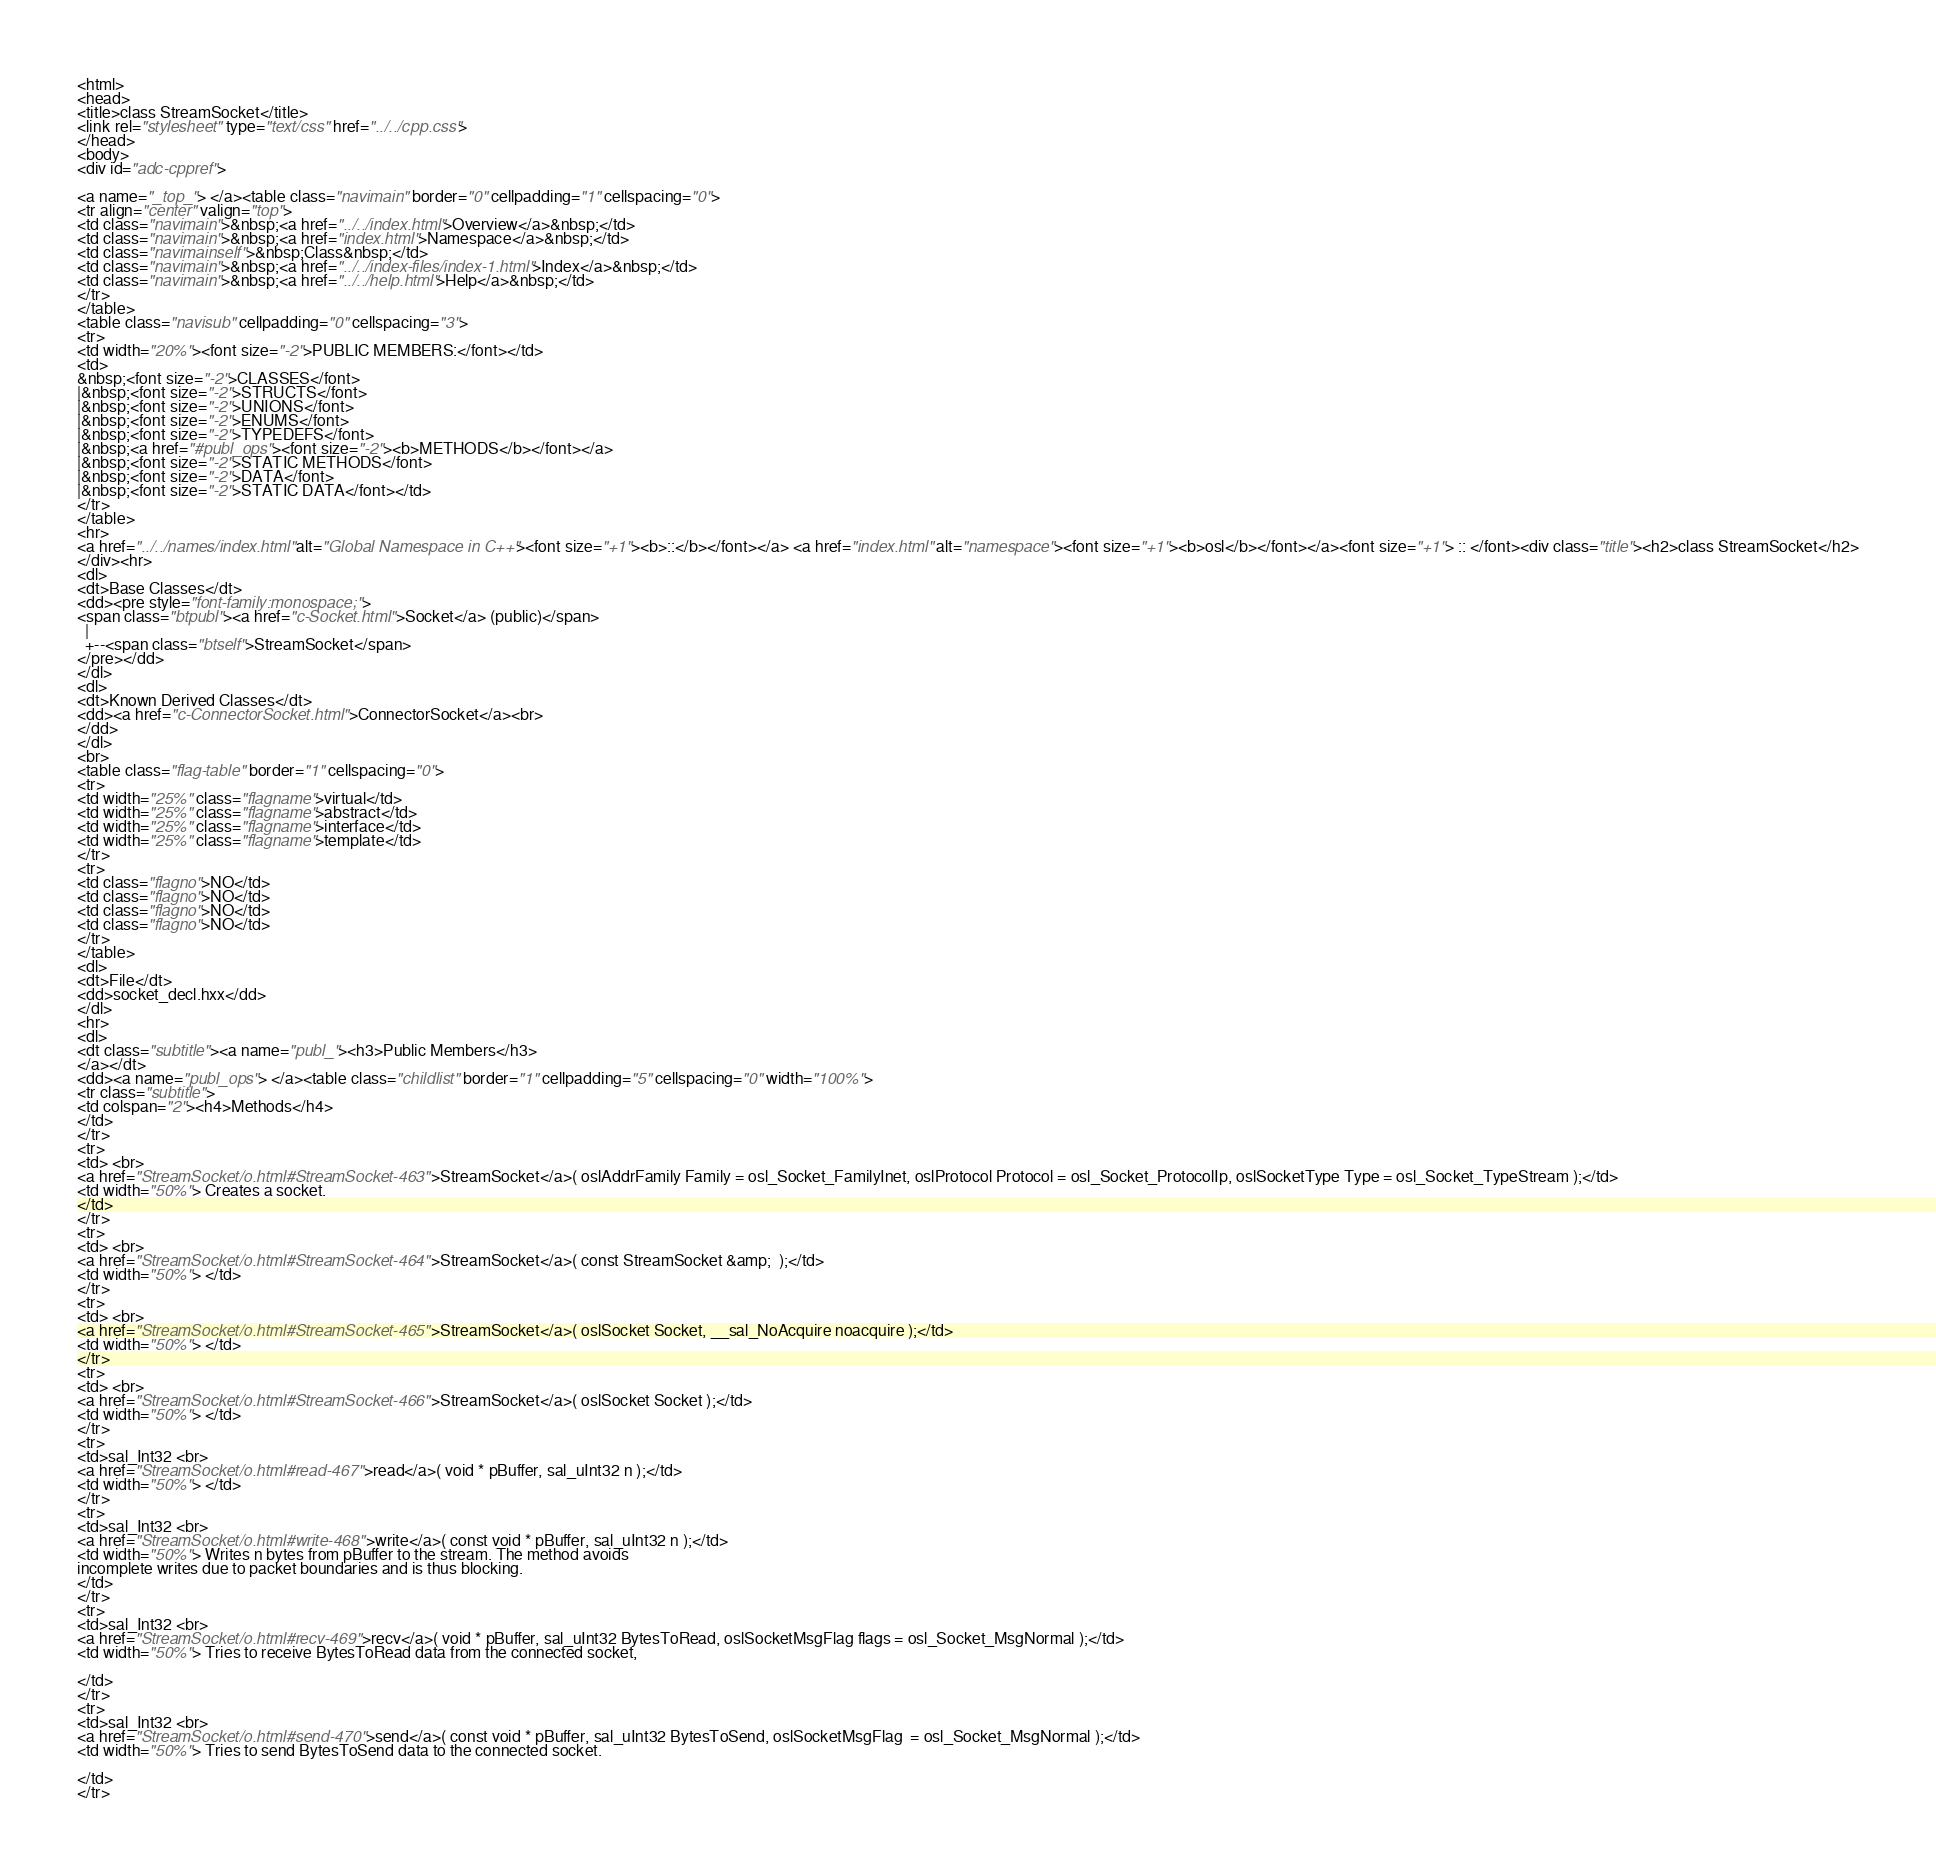<code> <loc_0><loc_0><loc_500><loc_500><_HTML_><html>
<head>
<title>class StreamSocket</title>
<link rel="stylesheet" type="text/css" href="../../cpp.css">
</head>
<body>
<div id="adc-cppref">

<a name="_top_"> </a><table class="navimain" border="0" cellpadding="1" cellspacing="0">
<tr align="center" valign="top">
<td class="navimain">&nbsp;<a href="../../index.html">Overview</a>&nbsp;</td>
<td class="navimain">&nbsp;<a href="index.html">Namespace</a>&nbsp;</td>
<td class="navimainself">&nbsp;Class&nbsp;</td>
<td class="navimain">&nbsp;<a href="../../index-files/index-1.html">Index</a>&nbsp;</td>
<td class="navimain">&nbsp;<a href="../../help.html">Help</a>&nbsp;</td>
</tr>
</table>
<table class="navisub" cellpadding="0" cellspacing="3">
<tr>
<td width="20%"><font size="-2">PUBLIC MEMBERS:</font></td>
<td>
&nbsp;<font size="-2">CLASSES</font>
|&nbsp;<font size="-2">STRUCTS</font>
|&nbsp;<font size="-2">UNIONS</font>
|&nbsp;<font size="-2">ENUMS</font>
|&nbsp;<font size="-2">TYPEDEFS</font>
|&nbsp;<a href="#publ_ops"><font size="-2"><b>METHODS</b></font></a>
|&nbsp;<font size="-2">STATIC METHODS</font>
|&nbsp;<font size="-2">DATA</font>
|&nbsp;<font size="-2">STATIC DATA</font></td>
</tr>
</table>
<hr>
<a href="../../names/index.html" alt="Global Namespace in C++"><font size="+1"><b>::</b></font></a> <a href="index.html" alt="namespace"><font size="+1"><b>osl</b></font></a><font size="+1"> :: </font><div class="title"><h2>class StreamSocket</h2>
</div><hr>
<dl>
<dt>Base Classes</dt>
<dd><pre style="font-family:monospace;">
<span class="btpubl"><a href="c-Socket.html">Socket</a> (public)</span>
  |  
  +--<span class="btself">StreamSocket</span>
</pre></dd>
</dl>
<dl>
<dt>Known Derived Classes</dt>
<dd><a href="c-ConnectorSocket.html">ConnectorSocket</a><br>
</dd>
</dl>
<br>
<table class="flag-table" border="1" cellspacing="0">
<tr>
<td width="25%" class="flagname">virtual</td>
<td width="25%" class="flagname">abstract</td>
<td width="25%" class="flagname">interface</td>
<td width="25%" class="flagname">template</td>
</tr>
<tr>
<td class="flagno">NO</td>
<td class="flagno">NO</td>
<td class="flagno">NO</td>
<td class="flagno">NO</td>
</tr>
</table>
<dl>
<dt>File</dt>
<dd>socket_decl.hxx</dd>
</dl>
<hr>
<dl>
<dt class="subtitle"><a name="publ_"><h3>Public Members</h3>
</a></dt>
<dd><a name="publ_ops"> </a><table class="childlist" border="1" cellpadding="5" cellspacing="0" width="100%">
<tr class="subtitle">
<td colspan="2"><h4>Methods</h4>
</td>
</tr>
<tr>
<td> <br>
<a href="StreamSocket/o.html#StreamSocket-463">StreamSocket</a>( oslAddrFamily Family = osl_Socket_FamilyInet, oslProtocol Protocol = osl_Socket_ProtocolIp, oslSocketType Type = osl_Socket_TypeStream );</td>
<td width="50%"> Creates a socket. 
</td>
</tr>
<tr>
<td> <br>
<a href="StreamSocket/o.html#StreamSocket-464">StreamSocket</a>( const StreamSocket &amp;  );</td>
<td width="50%"> </td>
</tr>
<tr>
<td> <br>
<a href="StreamSocket/o.html#StreamSocket-465">StreamSocket</a>( oslSocket Socket, __sal_NoAcquire noacquire );</td>
<td width="50%"> </td>
</tr>
<tr>
<td> <br>
<a href="StreamSocket/o.html#StreamSocket-466">StreamSocket</a>( oslSocket Socket );</td>
<td width="50%"> </td>
</tr>
<tr>
<td>sal_Int32 <br>
<a href="StreamSocket/o.html#read-467">read</a>( void * pBuffer, sal_uInt32 n );</td>
<td width="50%"> </td>
</tr>
<tr>
<td>sal_Int32 <br>
<a href="StreamSocket/o.html#write-468">write</a>( const void * pBuffer, sal_uInt32 n );</td>
<td width="50%"> Writes n bytes from pBuffer to the stream. The method avoids 
incomplete writes due to packet boundaries and is thus blocking.
</td>
</tr>
<tr>
<td>sal_Int32 <br>
<a href="StreamSocket/o.html#recv-469">recv</a>( void * pBuffer, sal_uInt32 BytesToRead, oslSocketMsgFlag flags = osl_Socket_MsgNormal );</td>
<td width="50%"> Tries to receive BytesToRead data from the connected socket,

</td>
</tr>
<tr>
<td>sal_Int32 <br>
<a href="StreamSocket/o.html#send-470">send</a>( const void * pBuffer, sal_uInt32 BytesToSend, oslSocketMsgFlag  = osl_Socket_MsgNormal );</td>
<td width="50%"> Tries to send BytesToSend data to the connected socket.

</td>
</tr></code> 